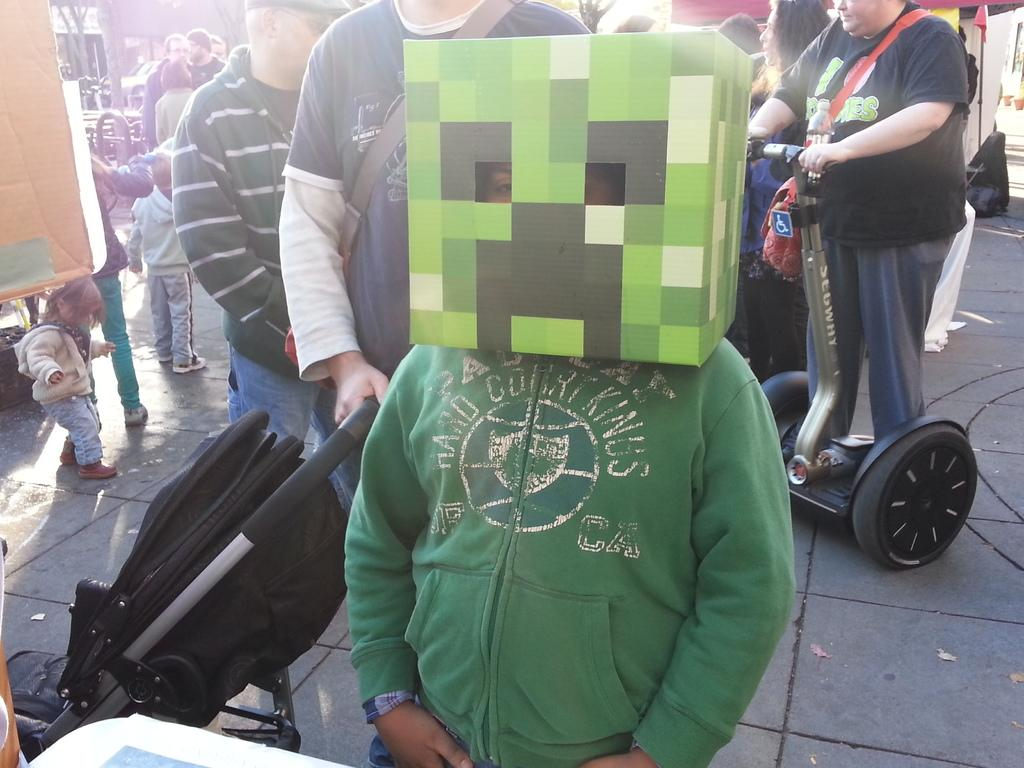What is the main subject in the center of the image? There is a person wearing a mask in the center of the image. What can be seen in the background of the image? There are people in the background of the image. What is visible at the bottom of the image? There is a floor visible at the bottom of the image. How many pies are being thrown in the air during the battle in the image? There is no battle or pies present in the image; it features a person wearing a mask and people in the background. What type of star can be seen in the image? There is no star present in the image. 